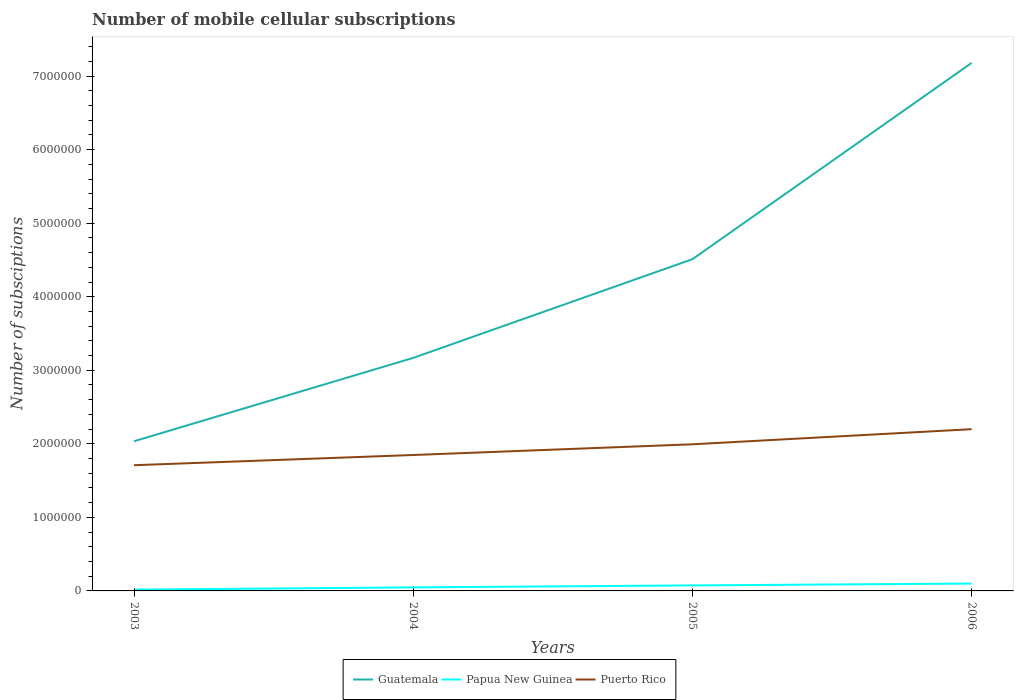Across all years, what is the maximum number of mobile cellular subscriptions in Puerto Rico?
Provide a succinct answer. 1.71e+06. In which year was the number of mobile cellular subscriptions in Puerto Rico maximum?
Your answer should be compact. 2003. What is the total number of mobile cellular subscriptions in Puerto Rico in the graph?
Offer a terse response. -4.90e+05. What is the difference between the highest and the second highest number of mobile cellular subscriptions in Papua New Guinea?
Your answer should be very brief. 8.25e+04. Is the number of mobile cellular subscriptions in Puerto Rico strictly greater than the number of mobile cellular subscriptions in Guatemala over the years?
Make the answer very short. Yes. How many years are there in the graph?
Offer a terse response. 4. What is the difference between two consecutive major ticks on the Y-axis?
Your answer should be very brief. 1.00e+06. Does the graph contain grids?
Make the answer very short. No. Where does the legend appear in the graph?
Your response must be concise. Bottom center. How are the legend labels stacked?
Keep it short and to the point. Horizontal. What is the title of the graph?
Your response must be concise. Number of mobile cellular subscriptions. What is the label or title of the X-axis?
Ensure brevity in your answer.  Years. What is the label or title of the Y-axis?
Offer a terse response. Number of subsciptions. What is the Number of subsciptions in Guatemala in 2003?
Make the answer very short. 2.03e+06. What is the Number of subsciptions of Papua New Guinea in 2003?
Provide a succinct answer. 1.75e+04. What is the Number of subsciptions in Puerto Rico in 2003?
Your answer should be compact. 1.71e+06. What is the Number of subsciptions in Guatemala in 2004?
Your response must be concise. 3.17e+06. What is the Number of subsciptions in Papua New Guinea in 2004?
Your answer should be compact. 4.83e+04. What is the Number of subsciptions in Puerto Rico in 2004?
Offer a terse response. 1.85e+06. What is the Number of subsciptions of Guatemala in 2005?
Provide a short and direct response. 4.51e+06. What is the Number of subsciptions in Papua New Guinea in 2005?
Your response must be concise. 7.50e+04. What is the Number of subsciptions of Puerto Rico in 2005?
Provide a succinct answer. 1.99e+06. What is the Number of subsciptions of Guatemala in 2006?
Offer a very short reply. 7.18e+06. What is the Number of subsciptions in Puerto Rico in 2006?
Keep it short and to the point. 2.20e+06. Across all years, what is the maximum Number of subsciptions of Guatemala?
Provide a short and direct response. 7.18e+06. Across all years, what is the maximum Number of subsciptions of Puerto Rico?
Provide a succinct answer. 2.20e+06. Across all years, what is the minimum Number of subsciptions in Guatemala?
Provide a short and direct response. 2.03e+06. Across all years, what is the minimum Number of subsciptions of Papua New Guinea?
Offer a very short reply. 1.75e+04. Across all years, what is the minimum Number of subsciptions of Puerto Rico?
Provide a succinct answer. 1.71e+06. What is the total Number of subsciptions of Guatemala in the graph?
Give a very brief answer. 1.69e+07. What is the total Number of subsciptions of Papua New Guinea in the graph?
Keep it short and to the point. 2.41e+05. What is the total Number of subsciptions in Puerto Rico in the graph?
Provide a succinct answer. 7.75e+06. What is the difference between the Number of subsciptions of Guatemala in 2003 and that in 2004?
Provide a succinct answer. -1.13e+06. What is the difference between the Number of subsciptions of Papua New Guinea in 2003 and that in 2004?
Your response must be concise. -3.08e+04. What is the difference between the Number of subsciptions of Puerto Rico in 2003 and that in 2004?
Your answer should be compact. -1.39e+05. What is the difference between the Number of subsciptions in Guatemala in 2003 and that in 2005?
Provide a succinct answer. -2.48e+06. What is the difference between the Number of subsciptions of Papua New Guinea in 2003 and that in 2005?
Your answer should be very brief. -5.75e+04. What is the difference between the Number of subsciptions of Puerto Rico in 2003 and that in 2005?
Ensure brevity in your answer.  -2.84e+05. What is the difference between the Number of subsciptions of Guatemala in 2003 and that in 2006?
Your answer should be very brief. -5.14e+06. What is the difference between the Number of subsciptions of Papua New Guinea in 2003 and that in 2006?
Your answer should be very brief. -8.25e+04. What is the difference between the Number of subsciptions of Puerto Rico in 2003 and that in 2006?
Offer a terse response. -4.90e+05. What is the difference between the Number of subsciptions of Guatemala in 2004 and that in 2005?
Your answer should be compact. -1.34e+06. What is the difference between the Number of subsciptions in Papua New Guinea in 2004 and that in 2005?
Make the answer very short. -2.67e+04. What is the difference between the Number of subsciptions in Puerto Rico in 2004 and that in 2005?
Make the answer very short. -1.46e+05. What is the difference between the Number of subsciptions of Guatemala in 2004 and that in 2006?
Make the answer very short. -4.01e+06. What is the difference between the Number of subsciptions in Papua New Guinea in 2004 and that in 2006?
Your answer should be compact. -5.17e+04. What is the difference between the Number of subsciptions of Puerto Rico in 2004 and that in 2006?
Your response must be concise. -3.51e+05. What is the difference between the Number of subsciptions of Guatemala in 2005 and that in 2006?
Provide a short and direct response. -2.67e+06. What is the difference between the Number of subsciptions in Papua New Guinea in 2005 and that in 2006?
Ensure brevity in your answer.  -2.50e+04. What is the difference between the Number of subsciptions of Puerto Rico in 2005 and that in 2006?
Provide a succinct answer. -2.05e+05. What is the difference between the Number of subsciptions in Guatemala in 2003 and the Number of subsciptions in Papua New Guinea in 2004?
Give a very brief answer. 1.99e+06. What is the difference between the Number of subsciptions of Guatemala in 2003 and the Number of subsciptions of Puerto Rico in 2004?
Make the answer very short. 1.87e+05. What is the difference between the Number of subsciptions in Papua New Guinea in 2003 and the Number of subsciptions in Puerto Rico in 2004?
Offer a very short reply. -1.83e+06. What is the difference between the Number of subsciptions in Guatemala in 2003 and the Number of subsciptions in Papua New Guinea in 2005?
Your answer should be compact. 1.96e+06. What is the difference between the Number of subsciptions of Guatemala in 2003 and the Number of subsciptions of Puerto Rico in 2005?
Make the answer very short. 4.13e+04. What is the difference between the Number of subsciptions in Papua New Guinea in 2003 and the Number of subsciptions in Puerto Rico in 2005?
Provide a succinct answer. -1.98e+06. What is the difference between the Number of subsciptions in Guatemala in 2003 and the Number of subsciptions in Papua New Guinea in 2006?
Offer a very short reply. 1.93e+06. What is the difference between the Number of subsciptions of Guatemala in 2003 and the Number of subsciptions of Puerto Rico in 2006?
Your response must be concise. -1.64e+05. What is the difference between the Number of subsciptions in Papua New Guinea in 2003 and the Number of subsciptions in Puerto Rico in 2006?
Your answer should be very brief. -2.18e+06. What is the difference between the Number of subsciptions of Guatemala in 2004 and the Number of subsciptions of Papua New Guinea in 2005?
Your answer should be compact. 3.09e+06. What is the difference between the Number of subsciptions of Guatemala in 2004 and the Number of subsciptions of Puerto Rico in 2005?
Offer a terse response. 1.17e+06. What is the difference between the Number of subsciptions of Papua New Guinea in 2004 and the Number of subsciptions of Puerto Rico in 2005?
Your answer should be compact. -1.95e+06. What is the difference between the Number of subsciptions in Guatemala in 2004 and the Number of subsciptions in Papua New Guinea in 2006?
Offer a terse response. 3.07e+06. What is the difference between the Number of subsciptions in Guatemala in 2004 and the Number of subsciptions in Puerto Rico in 2006?
Offer a very short reply. 9.69e+05. What is the difference between the Number of subsciptions in Papua New Guinea in 2004 and the Number of subsciptions in Puerto Rico in 2006?
Your response must be concise. -2.15e+06. What is the difference between the Number of subsciptions in Guatemala in 2005 and the Number of subsciptions in Papua New Guinea in 2006?
Your answer should be compact. 4.41e+06. What is the difference between the Number of subsciptions in Guatemala in 2005 and the Number of subsciptions in Puerto Rico in 2006?
Keep it short and to the point. 2.31e+06. What is the difference between the Number of subsciptions of Papua New Guinea in 2005 and the Number of subsciptions of Puerto Rico in 2006?
Keep it short and to the point. -2.12e+06. What is the average Number of subsciptions of Guatemala per year?
Your answer should be compact. 4.22e+06. What is the average Number of subsciptions in Papua New Guinea per year?
Offer a very short reply. 6.02e+04. What is the average Number of subsciptions of Puerto Rico per year?
Make the answer very short. 1.94e+06. In the year 2003, what is the difference between the Number of subsciptions in Guatemala and Number of subsciptions in Papua New Guinea?
Make the answer very short. 2.02e+06. In the year 2003, what is the difference between the Number of subsciptions in Guatemala and Number of subsciptions in Puerto Rico?
Offer a very short reply. 3.26e+05. In the year 2003, what is the difference between the Number of subsciptions of Papua New Guinea and Number of subsciptions of Puerto Rico?
Your response must be concise. -1.69e+06. In the year 2004, what is the difference between the Number of subsciptions of Guatemala and Number of subsciptions of Papua New Guinea?
Offer a very short reply. 3.12e+06. In the year 2004, what is the difference between the Number of subsciptions in Guatemala and Number of subsciptions in Puerto Rico?
Your response must be concise. 1.32e+06. In the year 2004, what is the difference between the Number of subsciptions of Papua New Guinea and Number of subsciptions of Puerto Rico?
Give a very brief answer. -1.80e+06. In the year 2005, what is the difference between the Number of subsciptions of Guatemala and Number of subsciptions of Papua New Guinea?
Ensure brevity in your answer.  4.44e+06. In the year 2005, what is the difference between the Number of subsciptions of Guatemala and Number of subsciptions of Puerto Rico?
Offer a terse response. 2.52e+06. In the year 2005, what is the difference between the Number of subsciptions of Papua New Guinea and Number of subsciptions of Puerto Rico?
Ensure brevity in your answer.  -1.92e+06. In the year 2006, what is the difference between the Number of subsciptions of Guatemala and Number of subsciptions of Papua New Guinea?
Your response must be concise. 7.08e+06. In the year 2006, what is the difference between the Number of subsciptions in Guatemala and Number of subsciptions in Puerto Rico?
Offer a very short reply. 4.98e+06. In the year 2006, what is the difference between the Number of subsciptions in Papua New Guinea and Number of subsciptions in Puerto Rico?
Give a very brief answer. -2.10e+06. What is the ratio of the Number of subsciptions in Guatemala in 2003 to that in 2004?
Offer a very short reply. 0.64. What is the ratio of the Number of subsciptions of Papua New Guinea in 2003 to that in 2004?
Keep it short and to the point. 0.36. What is the ratio of the Number of subsciptions in Puerto Rico in 2003 to that in 2004?
Offer a very short reply. 0.92. What is the ratio of the Number of subsciptions of Guatemala in 2003 to that in 2005?
Your answer should be compact. 0.45. What is the ratio of the Number of subsciptions in Papua New Guinea in 2003 to that in 2005?
Offer a very short reply. 0.23. What is the ratio of the Number of subsciptions in Puerto Rico in 2003 to that in 2005?
Your answer should be very brief. 0.86. What is the ratio of the Number of subsciptions in Guatemala in 2003 to that in 2006?
Offer a very short reply. 0.28. What is the ratio of the Number of subsciptions in Papua New Guinea in 2003 to that in 2006?
Make the answer very short. 0.17. What is the ratio of the Number of subsciptions in Puerto Rico in 2003 to that in 2006?
Ensure brevity in your answer.  0.78. What is the ratio of the Number of subsciptions in Guatemala in 2004 to that in 2005?
Offer a very short reply. 0.7. What is the ratio of the Number of subsciptions of Papua New Guinea in 2004 to that in 2005?
Give a very brief answer. 0.64. What is the ratio of the Number of subsciptions in Puerto Rico in 2004 to that in 2005?
Offer a very short reply. 0.93. What is the ratio of the Number of subsciptions in Guatemala in 2004 to that in 2006?
Offer a very short reply. 0.44. What is the ratio of the Number of subsciptions in Papua New Guinea in 2004 to that in 2006?
Offer a very short reply. 0.48. What is the ratio of the Number of subsciptions in Puerto Rico in 2004 to that in 2006?
Provide a succinct answer. 0.84. What is the ratio of the Number of subsciptions in Guatemala in 2005 to that in 2006?
Provide a short and direct response. 0.63. What is the ratio of the Number of subsciptions in Puerto Rico in 2005 to that in 2006?
Ensure brevity in your answer.  0.91. What is the difference between the highest and the second highest Number of subsciptions in Guatemala?
Provide a succinct answer. 2.67e+06. What is the difference between the highest and the second highest Number of subsciptions in Papua New Guinea?
Keep it short and to the point. 2.50e+04. What is the difference between the highest and the second highest Number of subsciptions of Puerto Rico?
Offer a terse response. 2.05e+05. What is the difference between the highest and the lowest Number of subsciptions of Guatemala?
Offer a terse response. 5.14e+06. What is the difference between the highest and the lowest Number of subsciptions of Papua New Guinea?
Offer a terse response. 8.25e+04. What is the difference between the highest and the lowest Number of subsciptions of Puerto Rico?
Offer a terse response. 4.90e+05. 